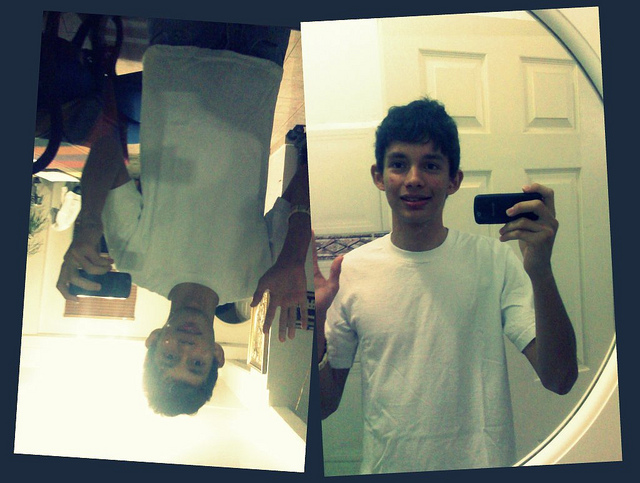How many phones can you spot in the image? There are two cellular telephones visible in the image: one held by the person in the direct selfie and one in the mirrored, upside-down reflection. 